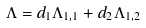Convert formula to latex. <formula><loc_0><loc_0><loc_500><loc_500>\Lambda = d _ { 1 } \Lambda _ { 1 , 1 } + d _ { 2 } \Lambda _ { 1 , 2 }</formula> 